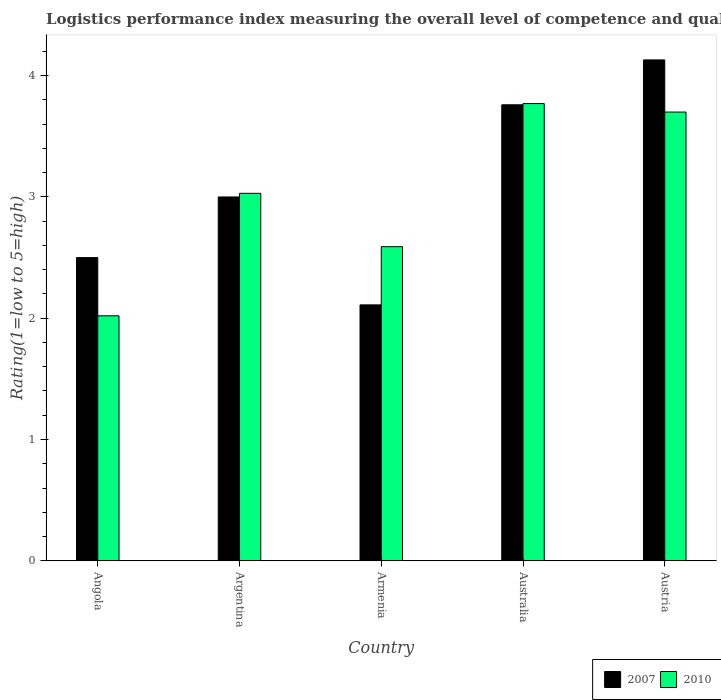How many groups of bars are there?
Give a very brief answer. 5. Are the number of bars per tick equal to the number of legend labels?
Ensure brevity in your answer.  Yes. How many bars are there on the 4th tick from the left?
Your answer should be very brief. 2. How many bars are there on the 3rd tick from the right?
Offer a very short reply. 2. What is the label of the 1st group of bars from the left?
Your answer should be compact. Angola. What is the Logistic performance index in 2007 in Angola?
Give a very brief answer. 2.5. Across all countries, what is the maximum Logistic performance index in 2010?
Keep it short and to the point. 3.77. Across all countries, what is the minimum Logistic performance index in 2010?
Provide a succinct answer. 2.02. In which country was the Logistic performance index in 2007 maximum?
Offer a very short reply. Austria. In which country was the Logistic performance index in 2007 minimum?
Make the answer very short. Armenia. What is the total Logistic performance index in 2010 in the graph?
Offer a very short reply. 15.11. What is the difference between the Logistic performance index in 2007 in Argentina and that in Armenia?
Provide a succinct answer. 0.89. What is the difference between the Logistic performance index in 2010 in Australia and the Logistic performance index in 2007 in Argentina?
Offer a terse response. 0.77. What is the average Logistic performance index in 2010 per country?
Give a very brief answer. 3.02. What is the difference between the Logistic performance index of/in 2007 and Logistic performance index of/in 2010 in Armenia?
Your answer should be very brief. -0.48. In how many countries, is the Logistic performance index in 2007 greater than 1.2?
Make the answer very short. 5. What is the ratio of the Logistic performance index in 2010 in Argentina to that in Australia?
Provide a short and direct response. 0.8. Is the Logistic performance index in 2007 in Armenia less than that in Australia?
Your response must be concise. Yes. Is the difference between the Logistic performance index in 2007 in Australia and Austria greater than the difference between the Logistic performance index in 2010 in Australia and Austria?
Give a very brief answer. No. What is the difference between the highest and the second highest Logistic performance index in 2007?
Provide a short and direct response. -0.76. What is the difference between the highest and the lowest Logistic performance index in 2007?
Your answer should be compact. 2.02. In how many countries, is the Logistic performance index in 2007 greater than the average Logistic performance index in 2007 taken over all countries?
Your answer should be very brief. 2. Is the sum of the Logistic performance index in 2010 in Australia and Austria greater than the maximum Logistic performance index in 2007 across all countries?
Ensure brevity in your answer.  Yes. What does the 1st bar from the left in Austria represents?
Keep it short and to the point. 2007. What does the 2nd bar from the right in Australia represents?
Your answer should be compact. 2007. How many countries are there in the graph?
Provide a short and direct response. 5. What is the difference between two consecutive major ticks on the Y-axis?
Your answer should be compact. 1. Are the values on the major ticks of Y-axis written in scientific E-notation?
Keep it short and to the point. No. Where does the legend appear in the graph?
Provide a succinct answer. Bottom right. How are the legend labels stacked?
Offer a terse response. Horizontal. What is the title of the graph?
Offer a very short reply. Logistics performance index measuring the overall level of competence and quality of logistics services. Does "1986" appear as one of the legend labels in the graph?
Provide a short and direct response. No. What is the label or title of the Y-axis?
Offer a terse response. Rating(1=low to 5=high). What is the Rating(1=low to 5=high) in 2007 in Angola?
Your response must be concise. 2.5. What is the Rating(1=low to 5=high) in 2010 in Angola?
Your answer should be very brief. 2.02. What is the Rating(1=low to 5=high) of 2010 in Argentina?
Your answer should be compact. 3.03. What is the Rating(1=low to 5=high) of 2007 in Armenia?
Make the answer very short. 2.11. What is the Rating(1=low to 5=high) in 2010 in Armenia?
Ensure brevity in your answer.  2.59. What is the Rating(1=low to 5=high) of 2007 in Australia?
Your answer should be compact. 3.76. What is the Rating(1=low to 5=high) in 2010 in Australia?
Make the answer very short. 3.77. What is the Rating(1=low to 5=high) in 2007 in Austria?
Your response must be concise. 4.13. Across all countries, what is the maximum Rating(1=low to 5=high) in 2007?
Keep it short and to the point. 4.13. Across all countries, what is the maximum Rating(1=low to 5=high) in 2010?
Keep it short and to the point. 3.77. Across all countries, what is the minimum Rating(1=low to 5=high) of 2007?
Your answer should be very brief. 2.11. Across all countries, what is the minimum Rating(1=low to 5=high) in 2010?
Your answer should be very brief. 2.02. What is the total Rating(1=low to 5=high) of 2010 in the graph?
Provide a succinct answer. 15.11. What is the difference between the Rating(1=low to 5=high) of 2010 in Angola and that in Argentina?
Offer a terse response. -1.01. What is the difference between the Rating(1=low to 5=high) of 2007 in Angola and that in Armenia?
Offer a very short reply. 0.39. What is the difference between the Rating(1=low to 5=high) of 2010 in Angola and that in Armenia?
Give a very brief answer. -0.57. What is the difference between the Rating(1=low to 5=high) in 2007 in Angola and that in Australia?
Keep it short and to the point. -1.26. What is the difference between the Rating(1=low to 5=high) in 2010 in Angola and that in Australia?
Your response must be concise. -1.75. What is the difference between the Rating(1=low to 5=high) of 2007 in Angola and that in Austria?
Ensure brevity in your answer.  -1.63. What is the difference between the Rating(1=low to 5=high) in 2010 in Angola and that in Austria?
Offer a very short reply. -1.68. What is the difference between the Rating(1=low to 5=high) in 2007 in Argentina and that in Armenia?
Offer a terse response. 0.89. What is the difference between the Rating(1=low to 5=high) in 2010 in Argentina and that in Armenia?
Provide a short and direct response. 0.44. What is the difference between the Rating(1=low to 5=high) of 2007 in Argentina and that in Australia?
Offer a terse response. -0.76. What is the difference between the Rating(1=low to 5=high) in 2010 in Argentina and that in Australia?
Give a very brief answer. -0.74. What is the difference between the Rating(1=low to 5=high) in 2007 in Argentina and that in Austria?
Provide a short and direct response. -1.13. What is the difference between the Rating(1=low to 5=high) in 2010 in Argentina and that in Austria?
Provide a short and direct response. -0.67. What is the difference between the Rating(1=low to 5=high) in 2007 in Armenia and that in Australia?
Offer a terse response. -1.65. What is the difference between the Rating(1=low to 5=high) in 2010 in Armenia and that in Australia?
Offer a terse response. -1.18. What is the difference between the Rating(1=low to 5=high) of 2007 in Armenia and that in Austria?
Your answer should be very brief. -2.02. What is the difference between the Rating(1=low to 5=high) in 2010 in Armenia and that in Austria?
Make the answer very short. -1.11. What is the difference between the Rating(1=low to 5=high) of 2007 in Australia and that in Austria?
Provide a succinct answer. -0.37. What is the difference between the Rating(1=low to 5=high) in 2010 in Australia and that in Austria?
Make the answer very short. 0.07. What is the difference between the Rating(1=low to 5=high) of 2007 in Angola and the Rating(1=low to 5=high) of 2010 in Argentina?
Make the answer very short. -0.53. What is the difference between the Rating(1=low to 5=high) in 2007 in Angola and the Rating(1=low to 5=high) in 2010 in Armenia?
Provide a short and direct response. -0.09. What is the difference between the Rating(1=low to 5=high) in 2007 in Angola and the Rating(1=low to 5=high) in 2010 in Australia?
Give a very brief answer. -1.27. What is the difference between the Rating(1=low to 5=high) of 2007 in Argentina and the Rating(1=low to 5=high) of 2010 in Armenia?
Keep it short and to the point. 0.41. What is the difference between the Rating(1=low to 5=high) in 2007 in Argentina and the Rating(1=low to 5=high) in 2010 in Australia?
Offer a very short reply. -0.77. What is the difference between the Rating(1=low to 5=high) in 2007 in Argentina and the Rating(1=low to 5=high) in 2010 in Austria?
Give a very brief answer. -0.7. What is the difference between the Rating(1=low to 5=high) of 2007 in Armenia and the Rating(1=low to 5=high) of 2010 in Australia?
Ensure brevity in your answer.  -1.66. What is the difference between the Rating(1=low to 5=high) of 2007 in Armenia and the Rating(1=low to 5=high) of 2010 in Austria?
Provide a short and direct response. -1.59. What is the average Rating(1=low to 5=high) of 2007 per country?
Provide a short and direct response. 3.1. What is the average Rating(1=low to 5=high) in 2010 per country?
Provide a succinct answer. 3.02. What is the difference between the Rating(1=low to 5=high) in 2007 and Rating(1=low to 5=high) in 2010 in Angola?
Keep it short and to the point. 0.48. What is the difference between the Rating(1=low to 5=high) of 2007 and Rating(1=low to 5=high) of 2010 in Argentina?
Your answer should be very brief. -0.03. What is the difference between the Rating(1=low to 5=high) in 2007 and Rating(1=low to 5=high) in 2010 in Armenia?
Keep it short and to the point. -0.48. What is the difference between the Rating(1=low to 5=high) of 2007 and Rating(1=low to 5=high) of 2010 in Australia?
Provide a succinct answer. -0.01. What is the difference between the Rating(1=low to 5=high) in 2007 and Rating(1=low to 5=high) in 2010 in Austria?
Offer a very short reply. 0.43. What is the ratio of the Rating(1=low to 5=high) in 2007 in Angola to that in Argentina?
Offer a terse response. 0.83. What is the ratio of the Rating(1=low to 5=high) of 2010 in Angola to that in Argentina?
Offer a very short reply. 0.67. What is the ratio of the Rating(1=low to 5=high) in 2007 in Angola to that in Armenia?
Keep it short and to the point. 1.18. What is the ratio of the Rating(1=low to 5=high) of 2010 in Angola to that in Armenia?
Offer a terse response. 0.78. What is the ratio of the Rating(1=low to 5=high) in 2007 in Angola to that in Australia?
Provide a succinct answer. 0.66. What is the ratio of the Rating(1=low to 5=high) of 2010 in Angola to that in Australia?
Offer a very short reply. 0.54. What is the ratio of the Rating(1=low to 5=high) of 2007 in Angola to that in Austria?
Provide a short and direct response. 0.61. What is the ratio of the Rating(1=low to 5=high) in 2010 in Angola to that in Austria?
Your answer should be very brief. 0.55. What is the ratio of the Rating(1=low to 5=high) of 2007 in Argentina to that in Armenia?
Give a very brief answer. 1.42. What is the ratio of the Rating(1=low to 5=high) in 2010 in Argentina to that in Armenia?
Your answer should be compact. 1.17. What is the ratio of the Rating(1=low to 5=high) of 2007 in Argentina to that in Australia?
Your answer should be very brief. 0.8. What is the ratio of the Rating(1=low to 5=high) in 2010 in Argentina to that in Australia?
Your response must be concise. 0.8. What is the ratio of the Rating(1=low to 5=high) in 2007 in Argentina to that in Austria?
Your answer should be compact. 0.73. What is the ratio of the Rating(1=low to 5=high) of 2010 in Argentina to that in Austria?
Give a very brief answer. 0.82. What is the ratio of the Rating(1=low to 5=high) of 2007 in Armenia to that in Australia?
Your response must be concise. 0.56. What is the ratio of the Rating(1=low to 5=high) of 2010 in Armenia to that in Australia?
Offer a very short reply. 0.69. What is the ratio of the Rating(1=low to 5=high) in 2007 in Armenia to that in Austria?
Provide a short and direct response. 0.51. What is the ratio of the Rating(1=low to 5=high) of 2007 in Australia to that in Austria?
Ensure brevity in your answer.  0.91. What is the ratio of the Rating(1=low to 5=high) in 2010 in Australia to that in Austria?
Offer a very short reply. 1.02. What is the difference between the highest and the second highest Rating(1=low to 5=high) in 2007?
Your answer should be very brief. 0.37. What is the difference between the highest and the second highest Rating(1=low to 5=high) in 2010?
Offer a very short reply. 0.07. What is the difference between the highest and the lowest Rating(1=low to 5=high) of 2007?
Make the answer very short. 2.02. 